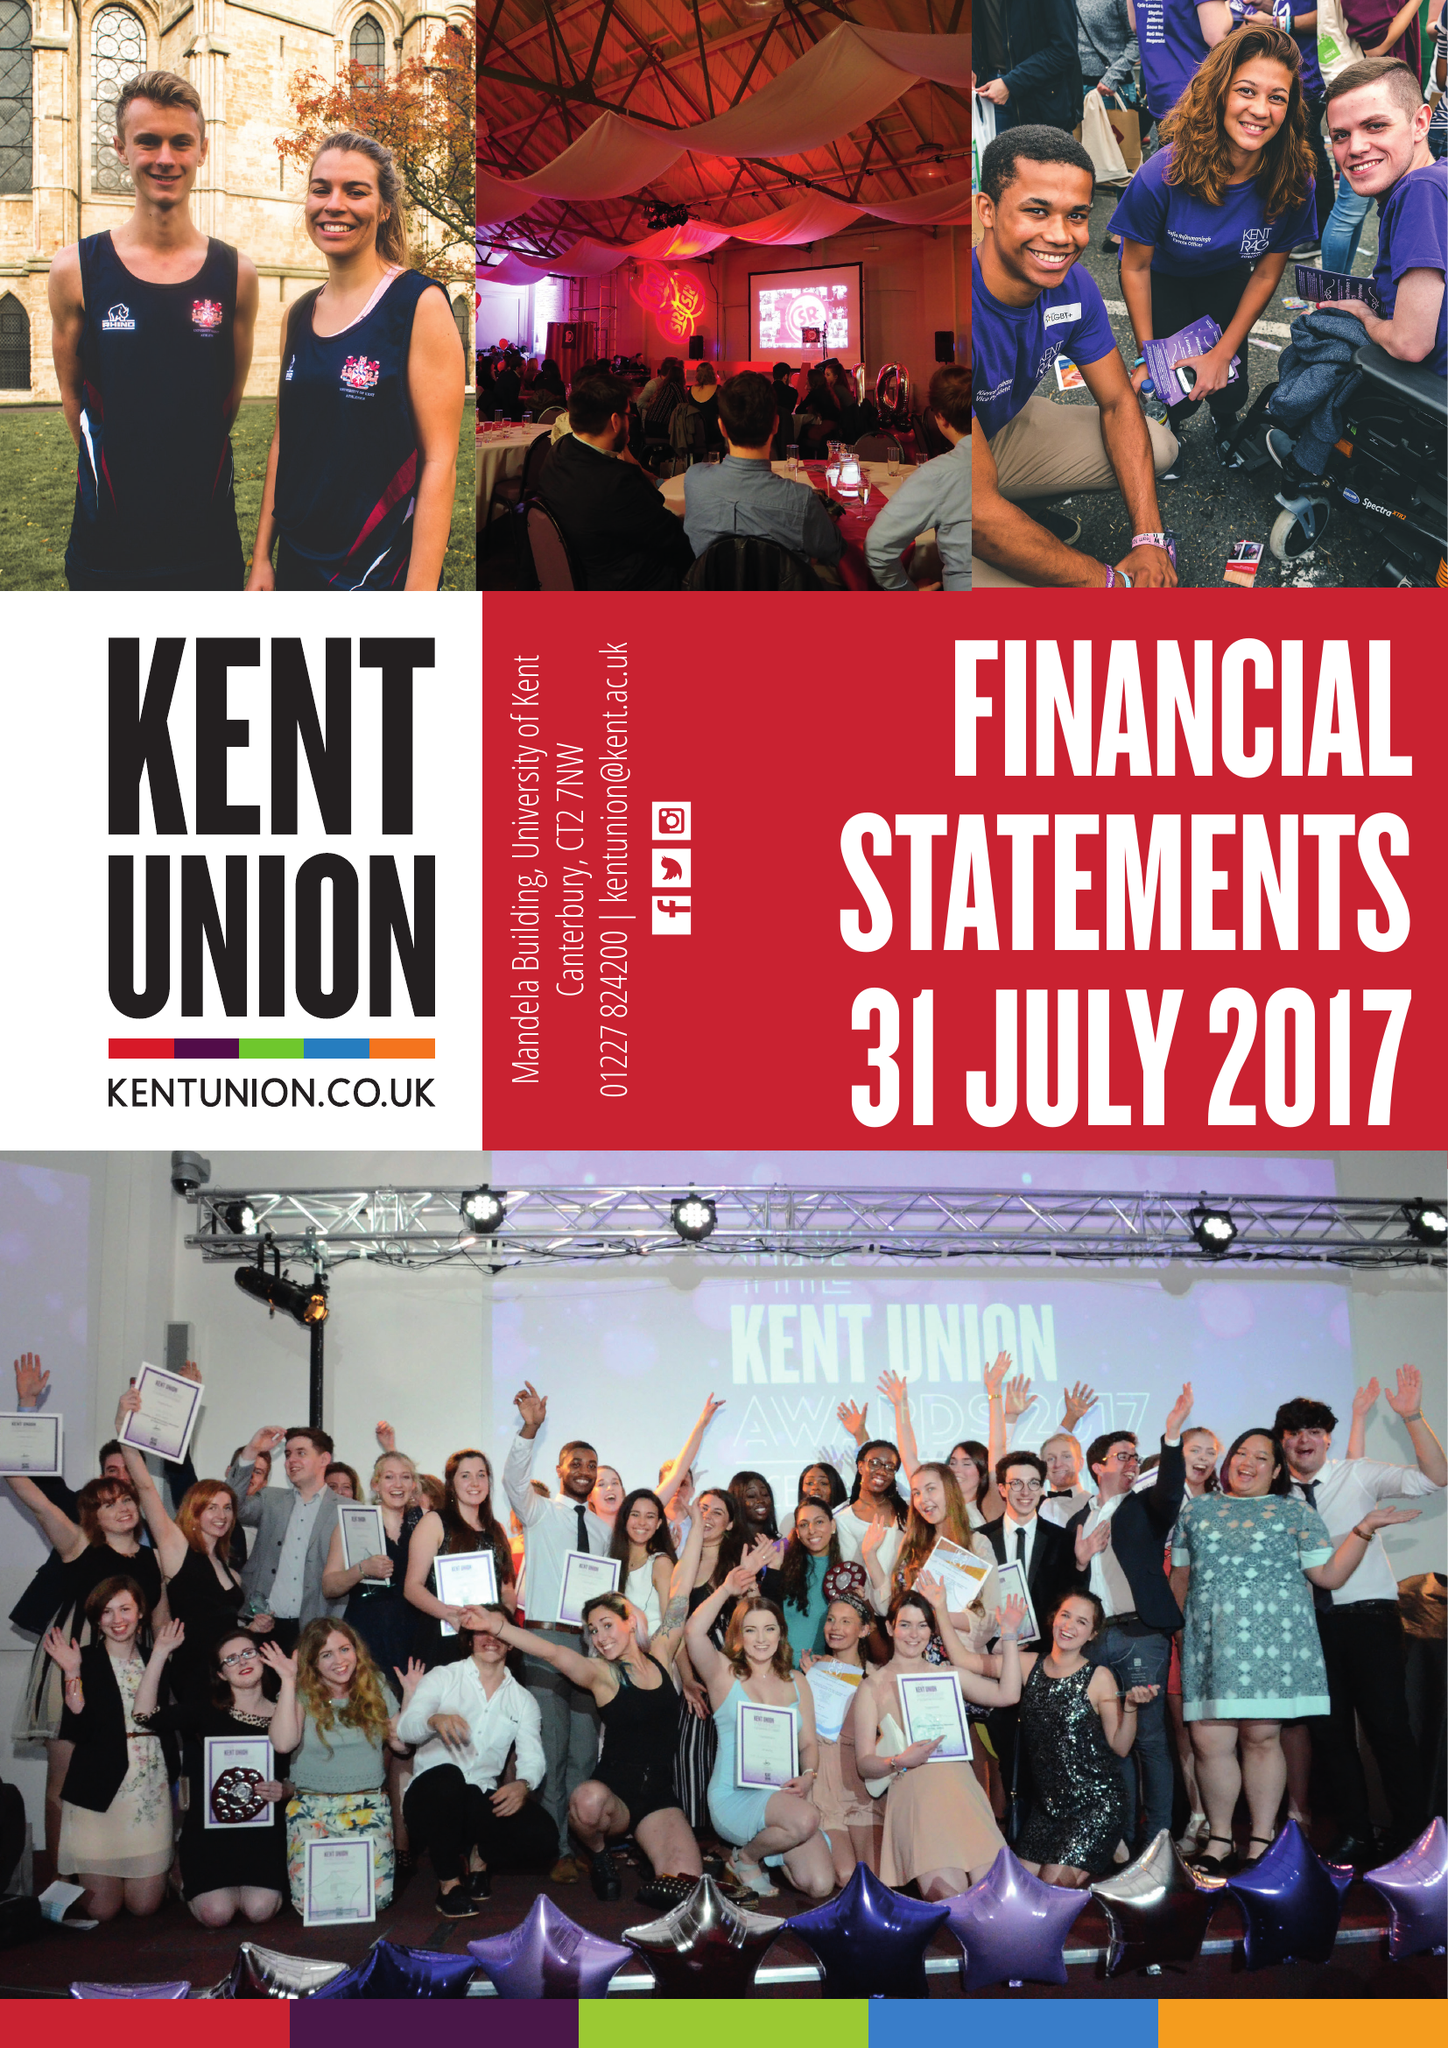What is the value for the charity_number?
Answer the question using a single word or phrase. 1138210 